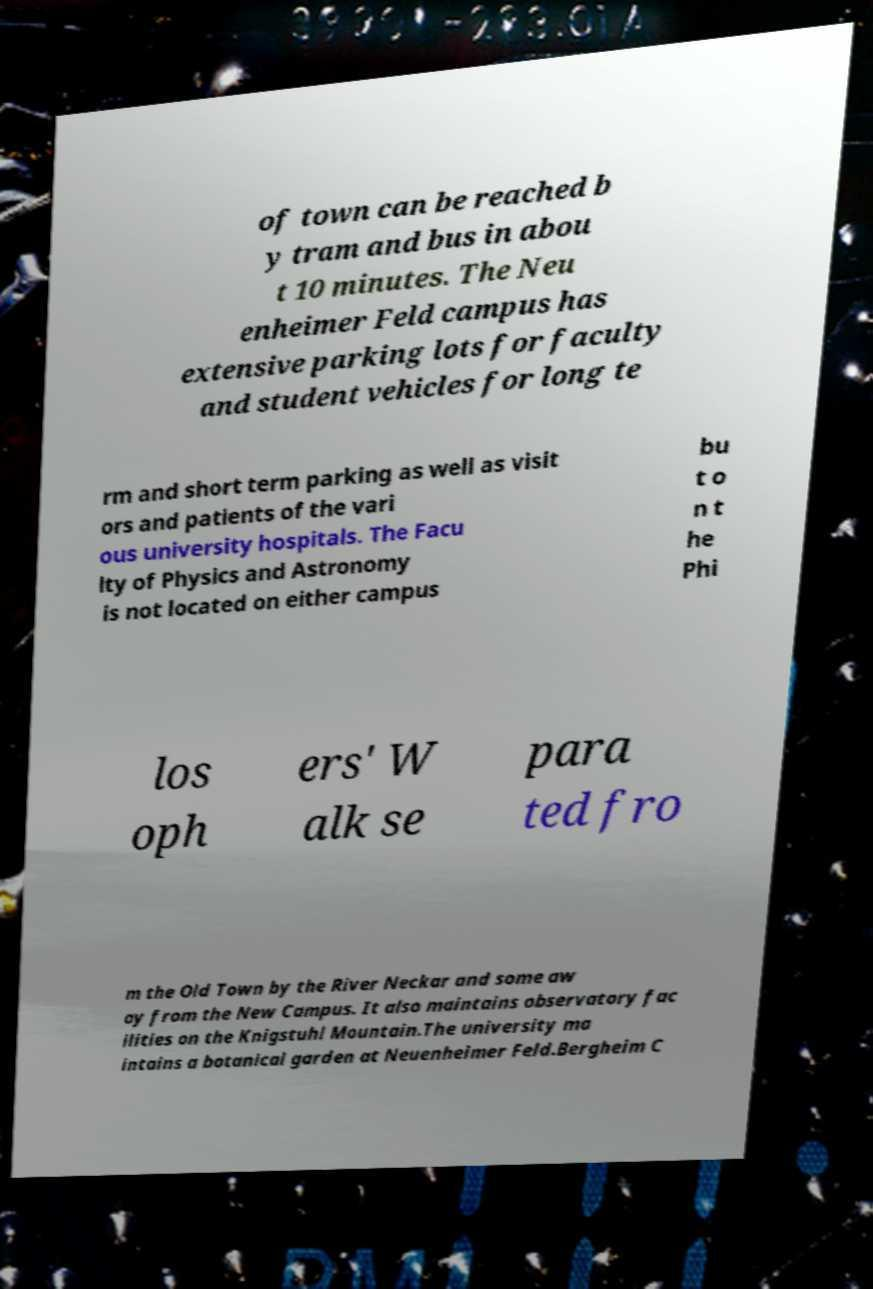For documentation purposes, I need the text within this image transcribed. Could you provide that? of town can be reached b y tram and bus in abou t 10 minutes. The Neu enheimer Feld campus has extensive parking lots for faculty and student vehicles for long te rm and short term parking as well as visit ors and patients of the vari ous university hospitals. The Facu lty of Physics and Astronomy is not located on either campus bu t o n t he Phi los oph ers' W alk se para ted fro m the Old Town by the River Neckar and some aw ay from the New Campus. It also maintains observatory fac ilities on the Knigstuhl Mountain.The university ma intains a botanical garden at Neuenheimer Feld.Bergheim C 